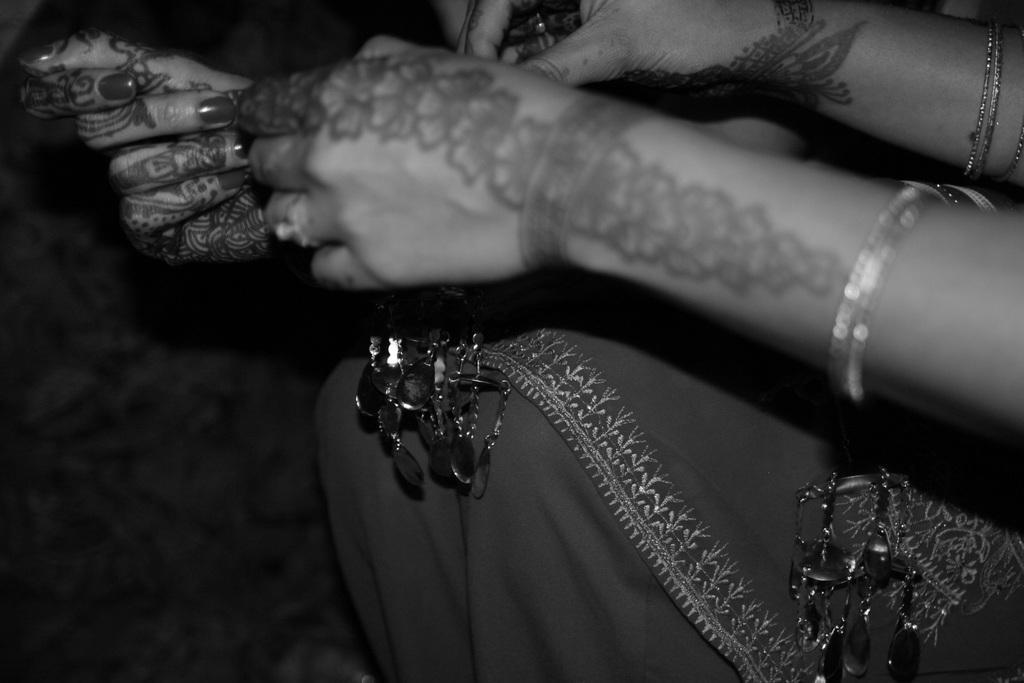Can you describe this image briefly? In this picture we can see some persons hands, bangles and in the background it is dark. 